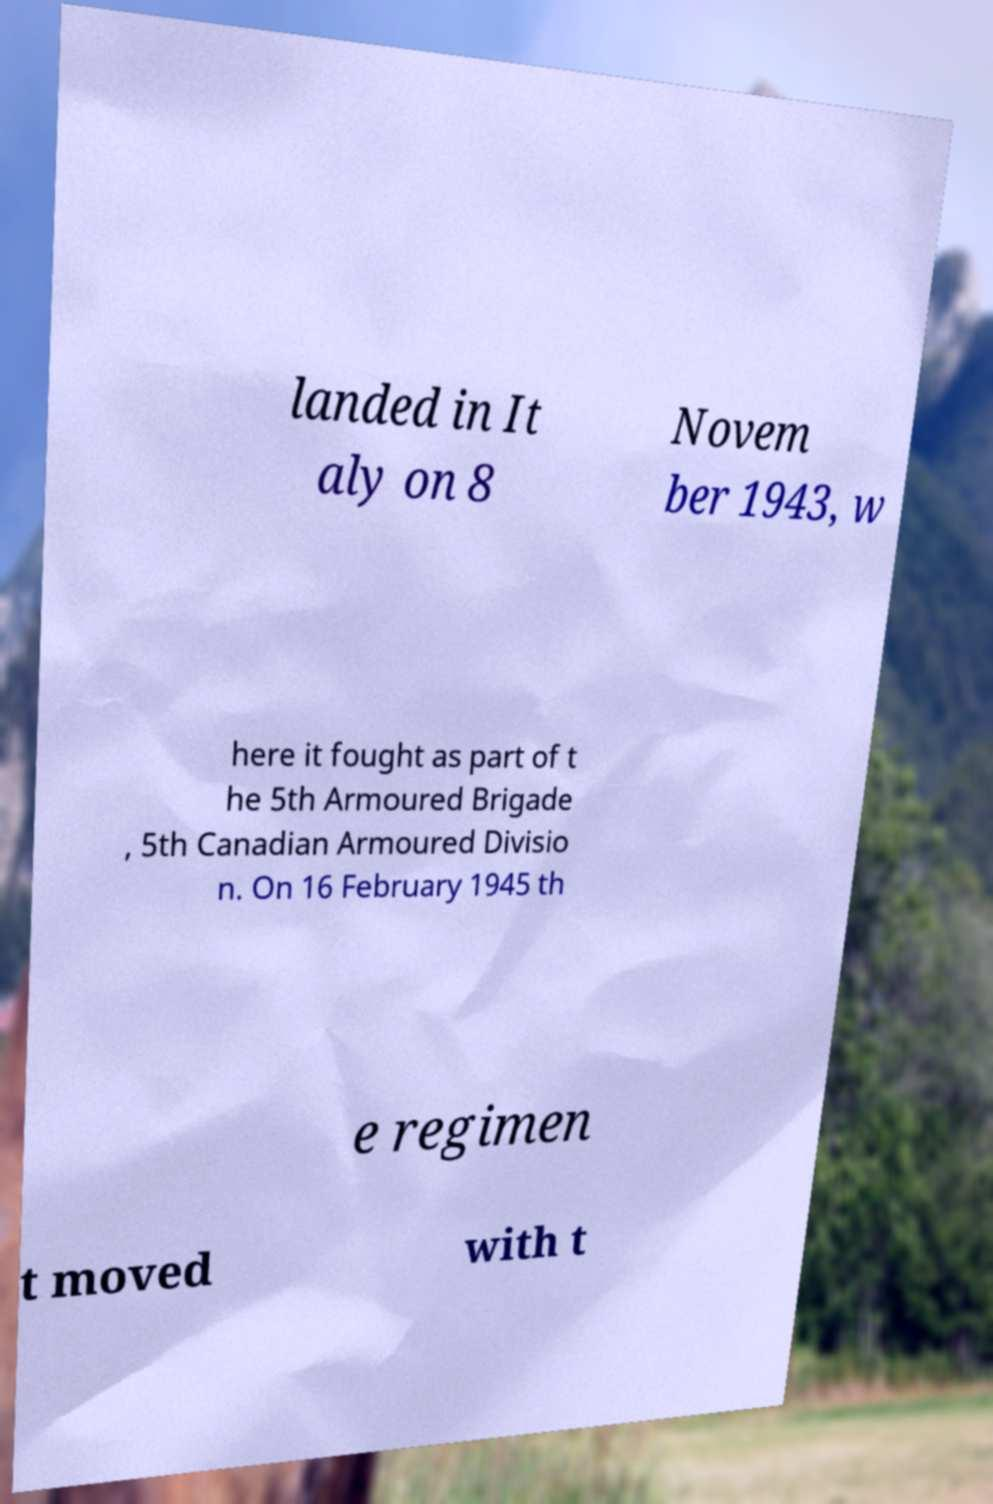For documentation purposes, I need the text within this image transcribed. Could you provide that? landed in It aly on 8 Novem ber 1943, w here it fought as part of t he 5th Armoured Brigade , 5th Canadian Armoured Divisio n. On 16 February 1945 th e regimen t moved with t 